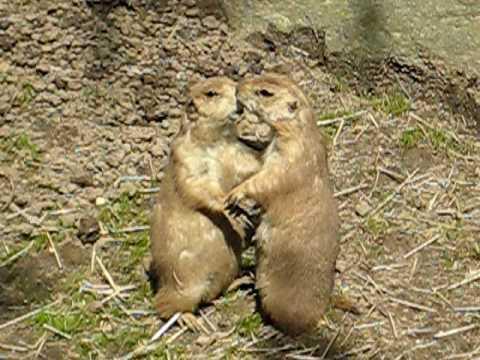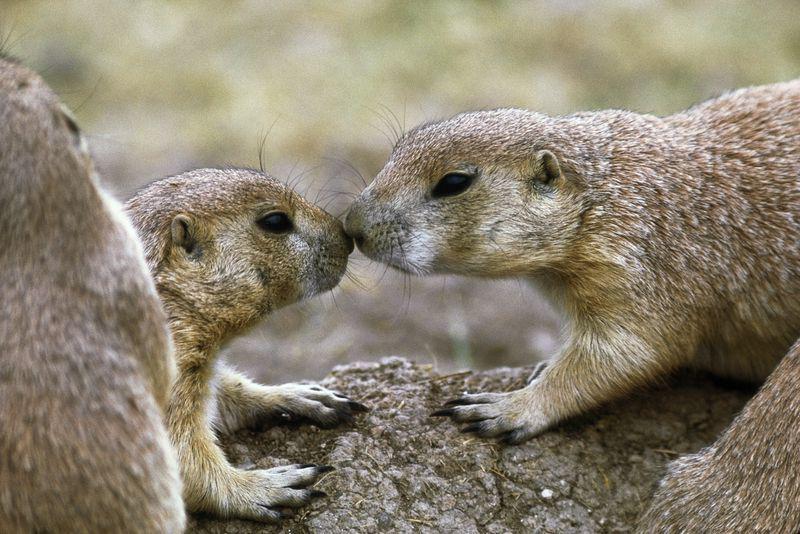The first image is the image on the left, the second image is the image on the right. Assess this claim about the two images: "There is a total of 4 prairie dogs.". Correct or not? Answer yes or no. Yes. The first image is the image on the left, the second image is the image on the right. Assess this claim about the two images: "The animals are facing each other in both images.". Correct or not? Answer yes or no. Yes. 